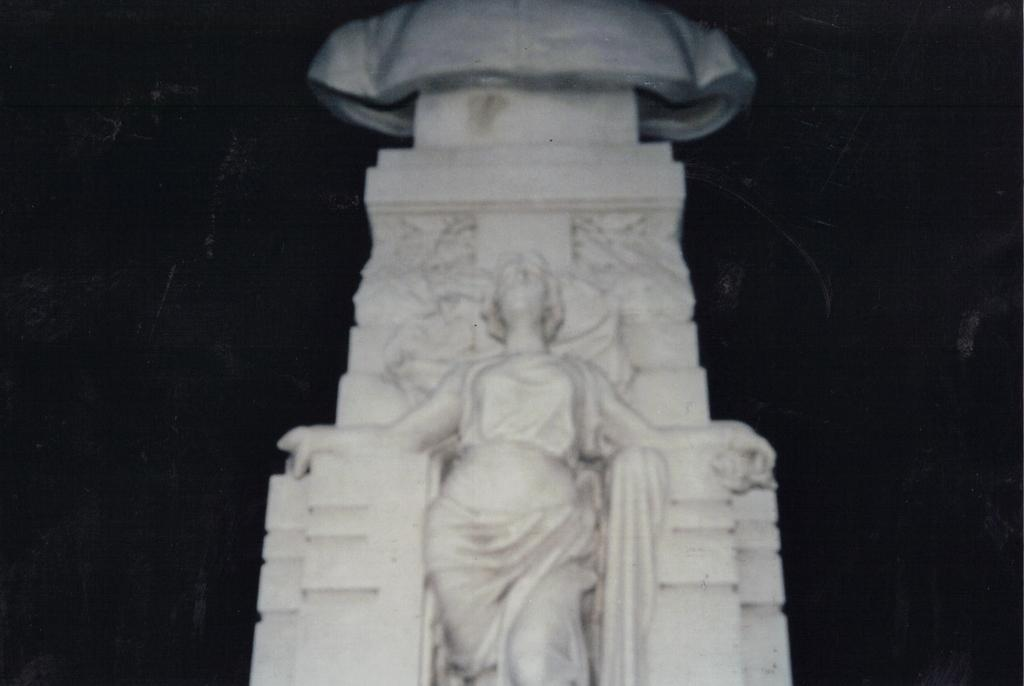What is the main subject of the image? The main subject of the image is a statue. What can be seen in the background of the image? The background of the image is dark. What type of agreement can be seen in the image? There is no agreement present in the image; it features a statue and a dark background. What type of office can be seen in the image? There is no office present in the image; it features a statue and a dark background. 